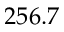<formula> <loc_0><loc_0><loc_500><loc_500>2 5 6 . 7</formula> 